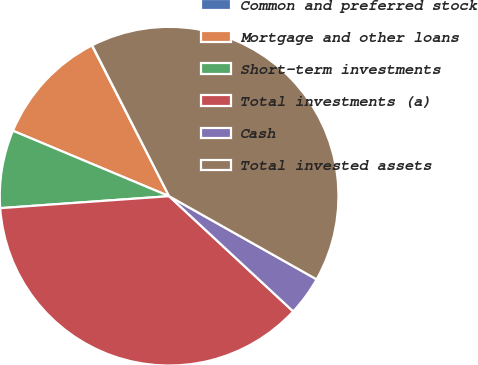<chart> <loc_0><loc_0><loc_500><loc_500><pie_chart><fcel>Common and preferred stock<fcel>Mortgage and other loans<fcel>Short-term investments<fcel>Total investments (a)<fcel>Cash<fcel>Total invested assets<nl><fcel>0.04%<fcel>11.14%<fcel>7.44%<fcel>36.96%<fcel>3.74%<fcel>40.67%<nl></chart> 